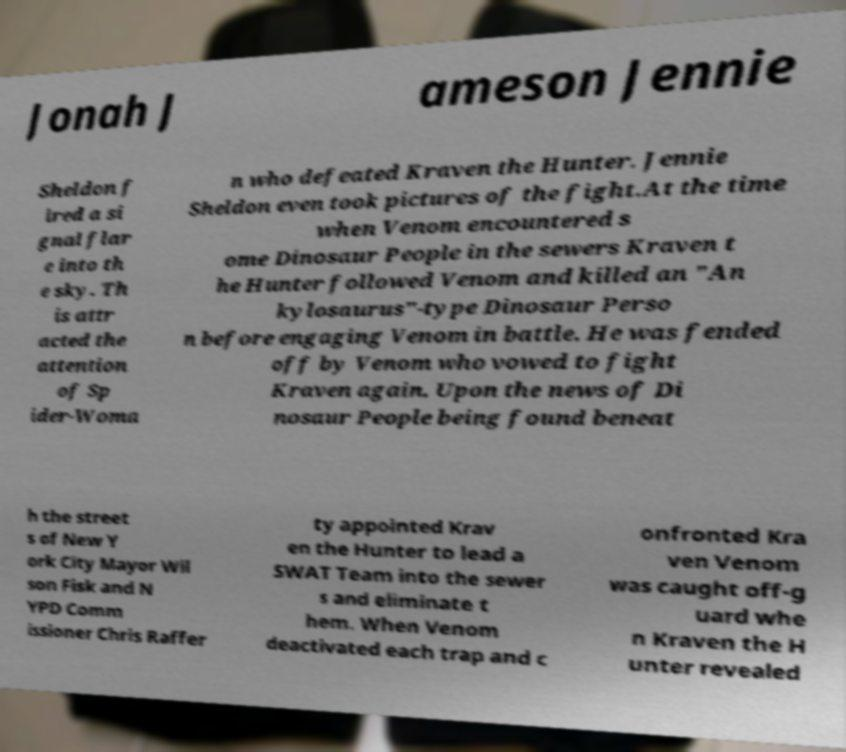Please read and relay the text visible in this image. What does it say? Jonah J ameson Jennie Sheldon f ired a si gnal flar e into th e sky. Th is attr acted the attention of Sp ider-Woma n who defeated Kraven the Hunter. Jennie Sheldon even took pictures of the fight.At the time when Venom encountered s ome Dinosaur People in the sewers Kraven t he Hunter followed Venom and killed an "An kylosaurus"-type Dinosaur Perso n before engaging Venom in battle. He was fended off by Venom who vowed to fight Kraven again. Upon the news of Di nosaur People being found beneat h the street s of New Y ork City Mayor Wil son Fisk and N YPD Comm issioner Chris Raffer ty appointed Krav en the Hunter to lead a SWAT Team into the sewer s and eliminate t hem. When Venom deactivated each trap and c onfronted Kra ven Venom was caught off-g uard whe n Kraven the H unter revealed 